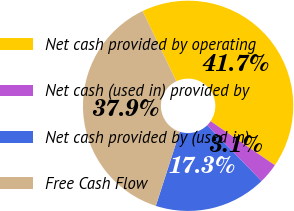<chart> <loc_0><loc_0><loc_500><loc_500><pie_chart><fcel>Net cash provided by operating<fcel>Net cash (used in) provided by<fcel>Net cash provided by (used in)<fcel>Free Cash Flow<nl><fcel>41.68%<fcel>3.14%<fcel>17.27%<fcel>37.9%<nl></chart> 